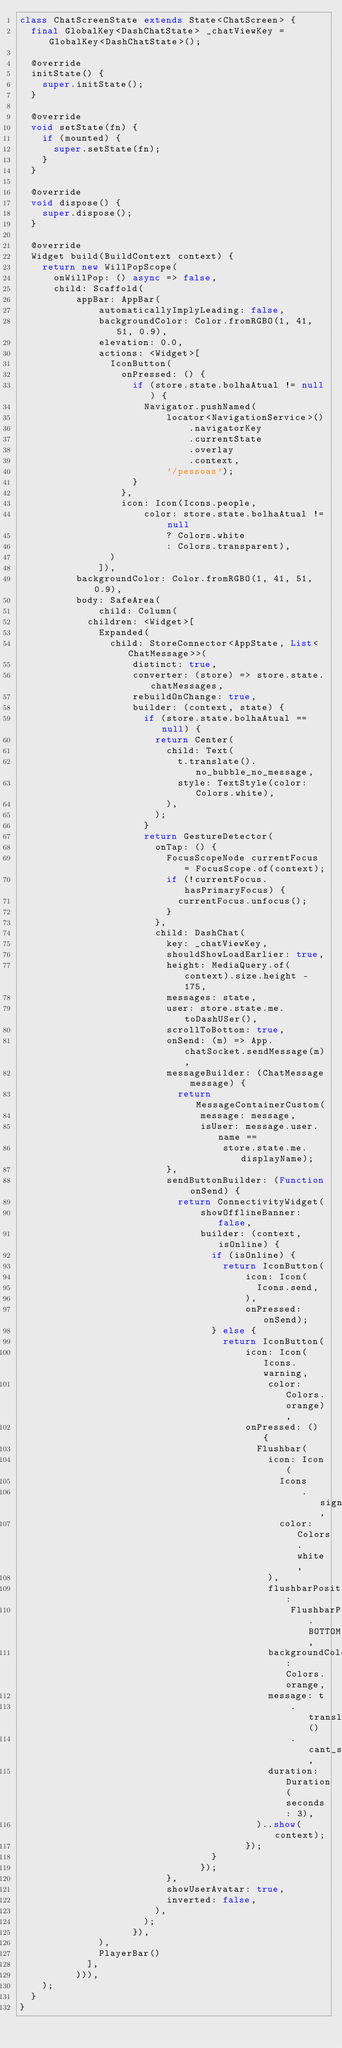Convert code to text. <code><loc_0><loc_0><loc_500><loc_500><_Dart_>class ChatScreenState extends State<ChatScreen> {
  final GlobalKey<DashChatState> _chatViewKey = GlobalKey<DashChatState>();

  @override
  initState() {
    super.initState();
  }

  @override
  void setState(fn) {
    if (mounted) {
      super.setState(fn);
    }
  }

  @override
  void dispose() {
    super.dispose();
  }

  @override
  Widget build(BuildContext context) {
    return new WillPopScope(
      onWillPop: () async => false,
      child: Scaffold(
          appBar: AppBar(
              automaticallyImplyLeading: false,
              backgroundColor: Color.fromRGBO(1, 41, 51, 0.9),
              elevation: 0.0,
              actions: <Widget>[
                IconButton(
                  onPressed: () {
                    if (store.state.bolhaAtual != null) {
                      Navigator.pushNamed(
                          locator<NavigationService>()
                              .navigatorKey
                              .currentState
                              .overlay
                              .context,
                          '/pessoas');
                    }
                  },
                  icon: Icon(Icons.people,
                      color: store.state.bolhaAtual != null
                          ? Colors.white
                          : Colors.transparent),
                )
              ]),
          backgroundColor: Color.fromRGBO(1, 41, 51, 0.9),
          body: SafeArea(
              child: Column(
            children: <Widget>[
              Expanded(
                child: StoreConnector<AppState, List<ChatMessage>>(
                    distinct: true,
                    converter: (store) => store.state.chatMessages,
                    rebuildOnChange: true,
                    builder: (context, state) {
                      if (store.state.bolhaAtual == null) {
                        return Center(
                          child: Text(
                            t.translate().no_bubble_no_message,
                            style: TextStyle(color: Colors.white),
                          ),
                        );
                      }
                      return GestureDetector(
                        onTap: () {
                          FocusScopeNode currentFocus = FocusScope.of(context);
                          if (!currentFocus.hasPrimaryFocus) {
                            currentFocus.unfocus();
                          }
                        },
                        child: DashChat(
                          key: _chatViewKey,
                          shouldShowLoadEarlier: true,
                          height: MediaQuery.of(context).size.height - 175,
                          messages: state,
                          user: store.state.me.toDashUSer(),
                          scrollToBottom: true,
                          onSend: (m) => App.chatSocket.sendMessage(m),
                          messageBuilder: (ChatMessage message) {
                            return MessageContainerCustom(
                                message: message,
                                isUser: message.user.name ==
                                    store.state.me.displayName);
                          },
                          sendButtonBuilder: (Function onSend) {
                            return ConnectivityWidget(
                                showOfflineBanner: false,
                                builder: (context, isOnline) {
                                  if (isOnline) {
                                    return IconButton(
                                        icon: Icon(
                                          Icons.send,
                                        ),
                                        onPressed: onSend);
                                  } else {
                                    return IconButton(
                                        icon: Icon(Icons.warning,
                                            color: Colors.orange),
                                        onPressed: () {
                                          Flushbar(
                                            icon: Icon(
                                              Icons
                                                  .signal_cellular_connected_no_internet_4_bar,
                                              color: Colors.white,
                                            ),
                                            flushbarPosition:
                                                FlushbarPosition.BOTTOM,
                                            backgroundColor: Colors.orange,
                                            message: t
                                                .translate()
                                                .cant_send_message_no_connection,
                                            duration: Duration(seconds: 3),
                                          )..show(context);
                                        });
                                  }
                                });
                          },
                          showUserAvatar: true,
                          inverted: false,
                        ),
                      );
                    }),
              ),
              PlayerBar()
            ],
          ))),
    );
  }
}
</code> 